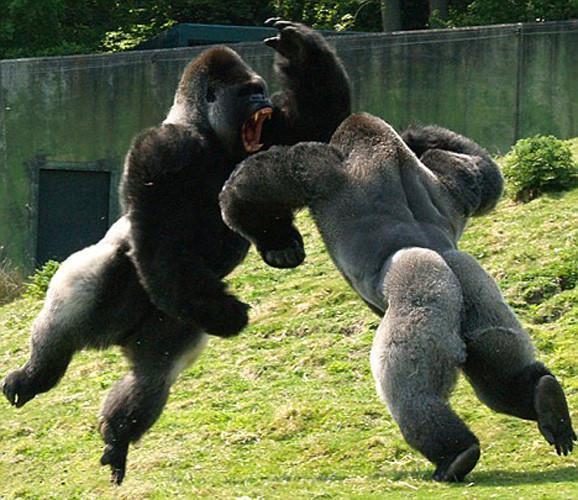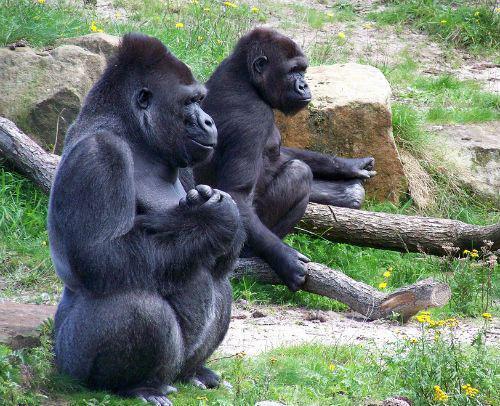The first image is the image on the left, the second image is the image on the right. Given the left and right images, does the statement "A baby gorilla is in front of a sitting adult gorilla with both hands touching its head, in one image." hold true? Answer yes or no. No. The first image is the image on the left, the second image is the image on the right. Considering the images on both sides, is "There are exactly three gorillas." valid? Answer yes or no. No. 